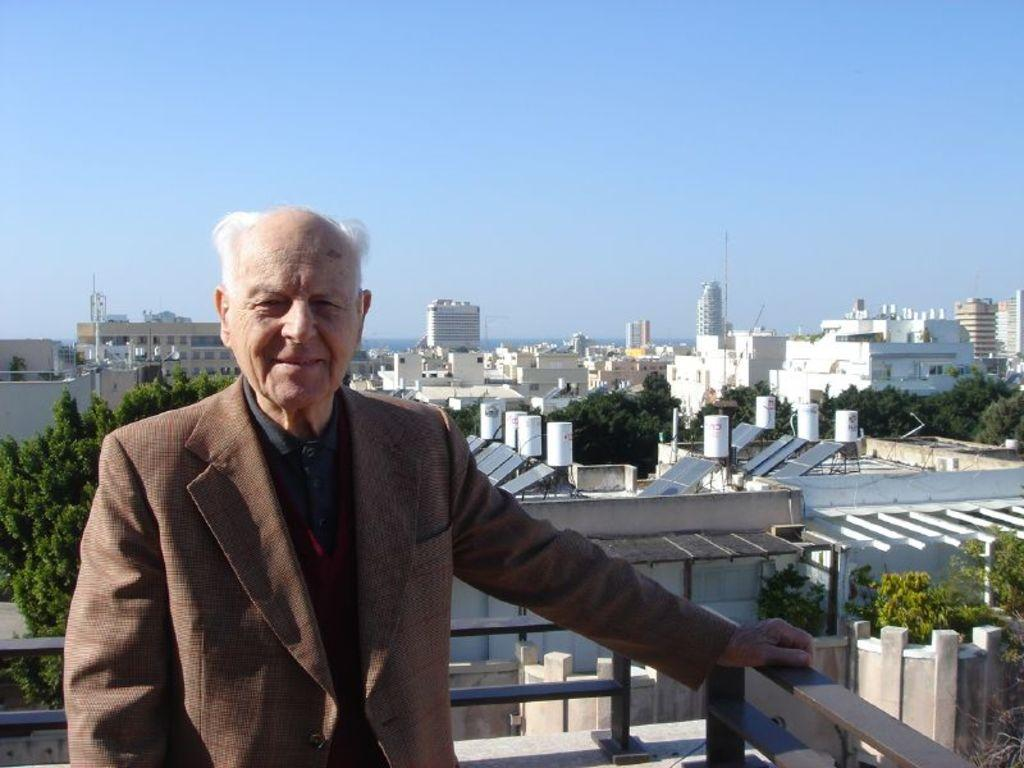What is the person in the image doing? The person is standing on a rooftop. What is the person holding onto while on the rooftop? The person is holding a railing. What can be seen in the distance behind the person? Buildings, solar panels, polls, and trees are visible in the background. What type of paper is the person holding in their hand in the image? There is no paper visible in the person's hand in the image. What emotion can be seen on the person's face in the image? The person's facial expression is not visible in the image, so it is impossible to determine their emotion. 